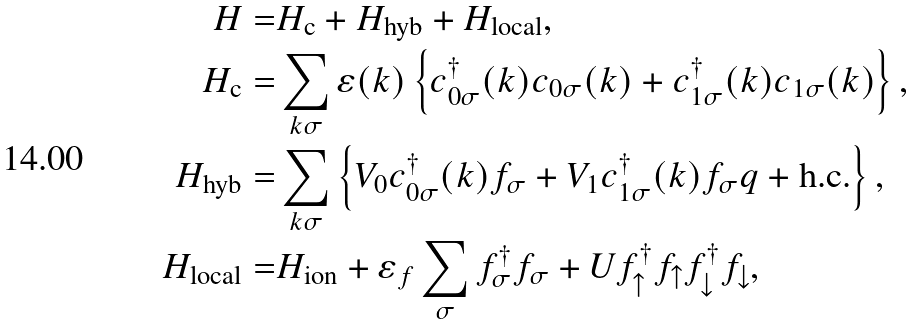Convert formula to latex. <formula><loc_0><loc_0><loc_500><loc_500>H = & H _ { \text {c} } + H _ { \text {hyb} } + H _ { \text {local} } , \\ H _ { \text {c} } = & \sum _ { k \sigma } \varepsilon ( k ) \left \{ c ^ { \dagger } _ { 0 \sigma } ( k ) c _ { 0 \sigma } ( k ) + c ^ { \dagger } _ { 1 \sigma } ( k ) c _ { 1 \sigma } ( k ) \right \} , \\ H _ { \text {hyb} } = & \sum _ { k \sigma } \left \{ V _ { 0 } c ^ { \dagger } _ { 0 \sigma } ( k ) f _ { \sigma } + V _ { 1 } c ^ { \dagger } _ { 1 \sigma } ( k ) f _ { \sigma } q + \text {h.c.} \right \} , \\ H _ { \text {local} } = & H _ { \text {ion} } + \varepsilon _ { f } \sum _ { \sigma } f ^ { \dagger } _ { \sigma } f _ { \sigma } + U f ^ { \dagger } _ { \uparrow } f _ { \uparrow } f ^ { \dagger } _ { \downarrow } f _ { \downarrow } ,</formula> 